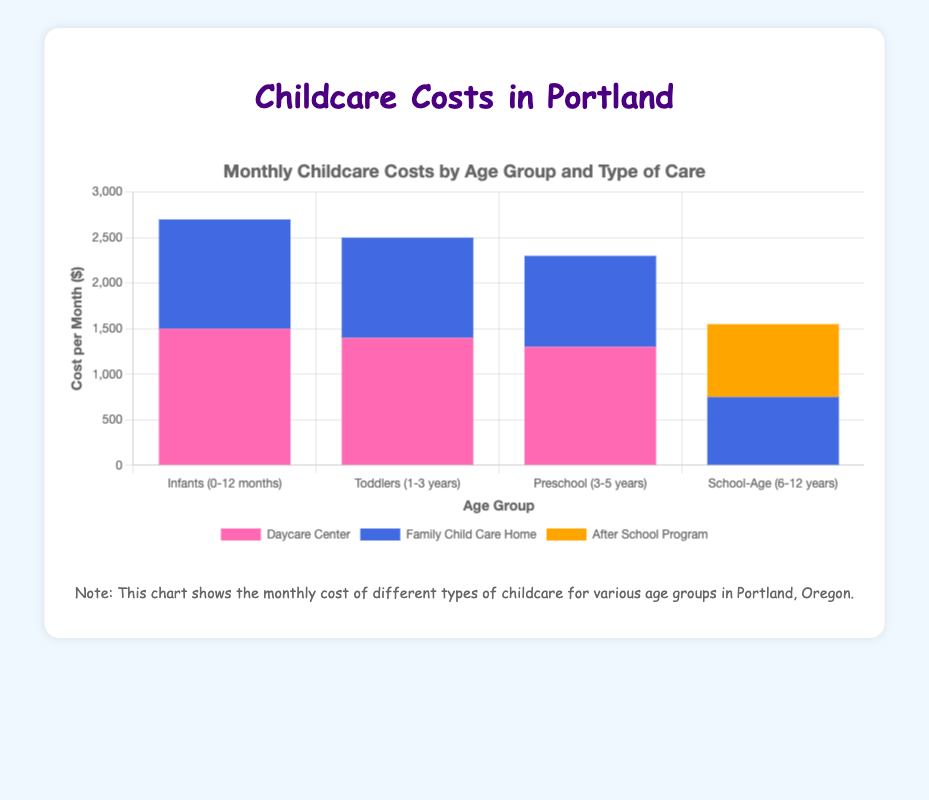What's the cost difference between Daycare Center and Family Child Care Home for Infants (0-12 months)? To find the cost difference for Infants (0-12 months), subtract the monthly cost of Family Child Care Home ($1200) from the monthly cost of the Daycare Center ($1500): $1500 - $1200 = $300
Answer: $300 Which type of care is the cheapest for School-Age (6-12 years) children? Compare the costs for both types of care for School-Age (6-12 years) children: After School Program ($800) and Family Child Care Home ($750). The cheapest type of care is the Family Child Care Home at $750 per month.
Answer: Family Child Care Home For which age group does the cost difference between Daycare Center and Family Child Care Home have the greatest absolute value? Calculate the cost difference for each age group:
Infants: $1500 - $1200 = $300
Toddlers: $1400 - $1100 = $300
Preschool: $1300 - $1000 = $300
School-Age: $800 - $750 = $50
The greatest absolute difference is $300, which occurs for Infants, Toddlers, and Preschool age groups.
Answer: Infants, Toddlers, Preschool Which age group has the lowest average cost, and what is that average? Calculate the average cost for each age group:
Infants: ($1500 + $1200)/2 = $1350
Toddlers: ($1400 + $1100)/2 = $1250
Preschool: ($1300 + $1000)/2 = $1150
School-Age: ($800 + $750)/2 = $775
The lowest average cost is for the School-Age (6-12 years) group, which is $775.
Answer: School-Age (6-12 years), $775 Is there any type of care that is cheaper for all age groups? Compare the costs of Daycare Center and Family Child Care Home for each age group. Family Child Care Home is cheaper for:
Infants: $1200 < $1500
Toddlers: $1100 < $1400
Preschool: $1000 < $1300
School-Age: $750 < $800
Family Child Care Home is indeed cheaper for all age groups.
Answer: Yes, Family Child Care Home How much more expensive is childcare for Toddlers (1-3 years) in Daycare Centers compared to Preschool (3-5 years) in Family Child Care Homes? Calculate the cost for Toddlers in Daycare Centers ($1400) and subtract the cost for Preschool in Family Child Care Homes ($1000): $1400 - $1000 = $400
Answer: $400 What are the total costs for all types of care combined for each age group? Sum the costs for all types of care for each age group:
Infants: $1500 (Daycare) + $1200 (Family) = $2700
Toddlers: $1400 (Daycare) + $1100 (Family) = $2500
Preschool: $1300 (Daycare) + $1000 (Family) = $2300
School-Age: $800 (After School) + $750 (Family) = $1550
Answer: Infants: $2700, Toddlers: $2500, Preschool: $2300, School-Age: $1550 